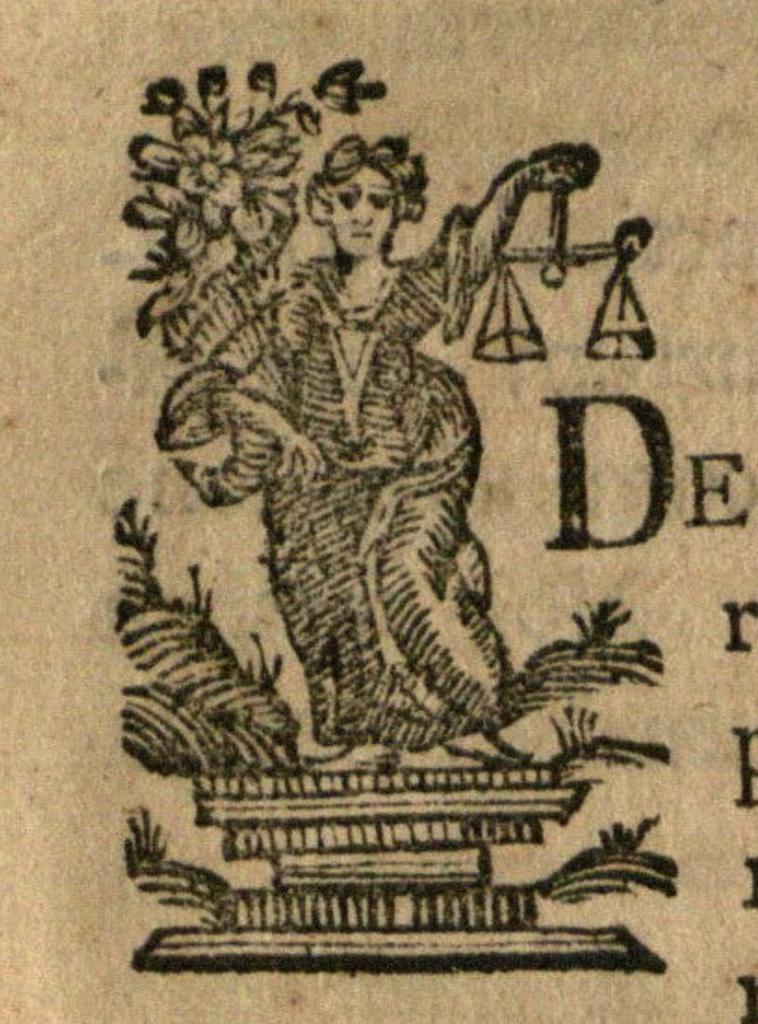<image>
Present a compact description of the photo's key features. The letters DE can be seen next to a picture of a woman holding scales. 